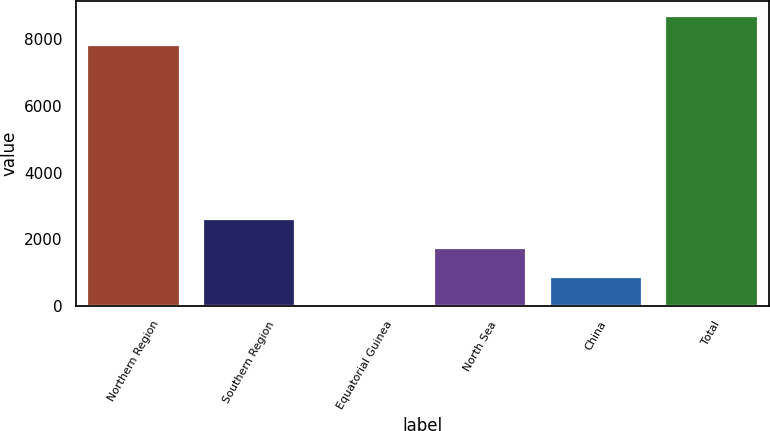<chart> <loc_0><loc_0><loc_500><loc_500><bar_chart><fcel>Northern Region<fcel>Southern Region<fcel>Equatorial Guinea<fcel>North Sea<fcel>China<fcel>Total<nl><fcel>7825<fcel>2602.3<fcel>4<fcel>1736.2<fcel>870.1<fcel>8691.1<nl></chart> 